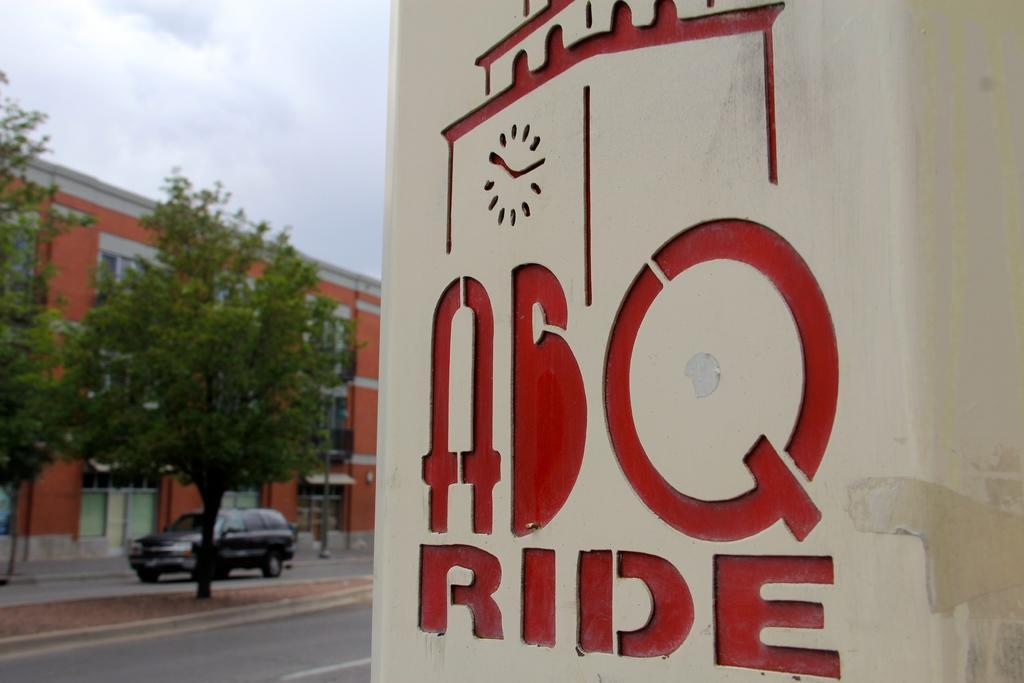In one or two sentences, can you explain what this image depicts? There is a wall which has something written on it in red color and there are trees,building and a vehicle in the left corner. 